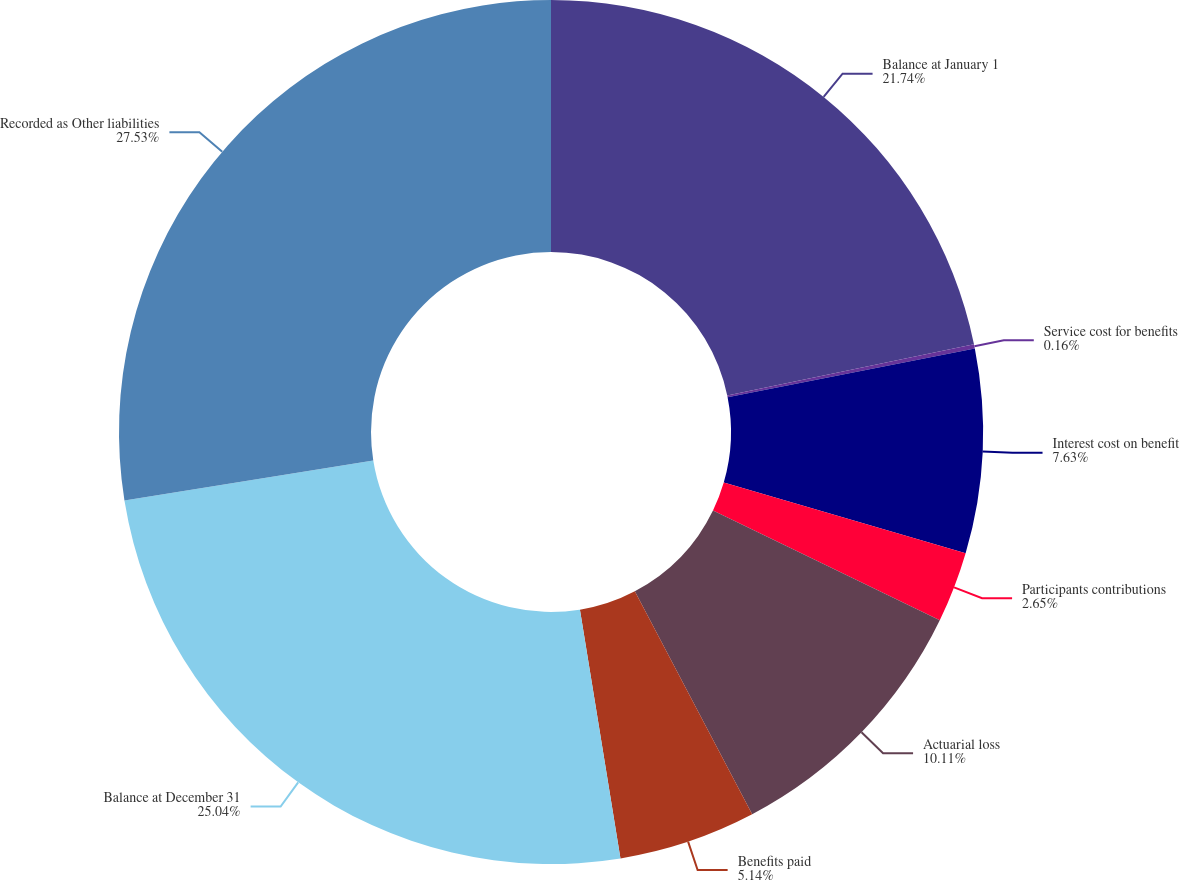Convert chart. <chart><loc_0><loc_0><loc_500><loc_500><pie_chart><fcel>Balance at January 1<fcel>Service cost for benefits<fcel>Interest cost on benefit<fcel>Participants contributions<fcel>Actuarial loss<fcel>Benefits paid<fcel>Balance at December 31<fcel>Recorded as Other liabilities<nl><fcel>21.74%<fcel>0.16%<fcel>7.63%<fcel>2.65%<fcel>10.11%<fcel>5.14%<fcel>25.04%<fcel>27.53%<nl></chart> 